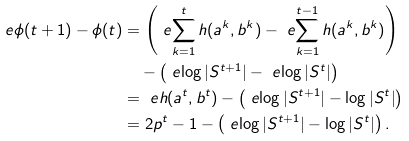<formula> <loc_0><loc_0><loc_500><loc_500>\ e { \phi ( t + 1 ) - \phi ( t ) } & = \left ( \ e { \sum _ { k = 1 } ^ { t } h ( a ^ { k } , b ^ { k } ) } - \ e { \sum _ { k = 1 } ^ { t - 1 } h ( a ^ { k } , b ^ { k } ) } \right ) \\ & \quad - \left ( \ e { \log | S ^ { t + 1 } | } - \ e { \log | S ^ { t } | } \right ) \\ & = \ e { h ( a ^ { t } , b ^ { t } ) } - \left ( \ e { \log | S ^ { t + 1 } | - \log | S ^ { t } | } \right ) \\ & = 2 p ^ { t } - 1 - \left ( \ e { \log | S ^ { t + 1 } | - \log | S ^ { t } | } \right ) .</formula> 